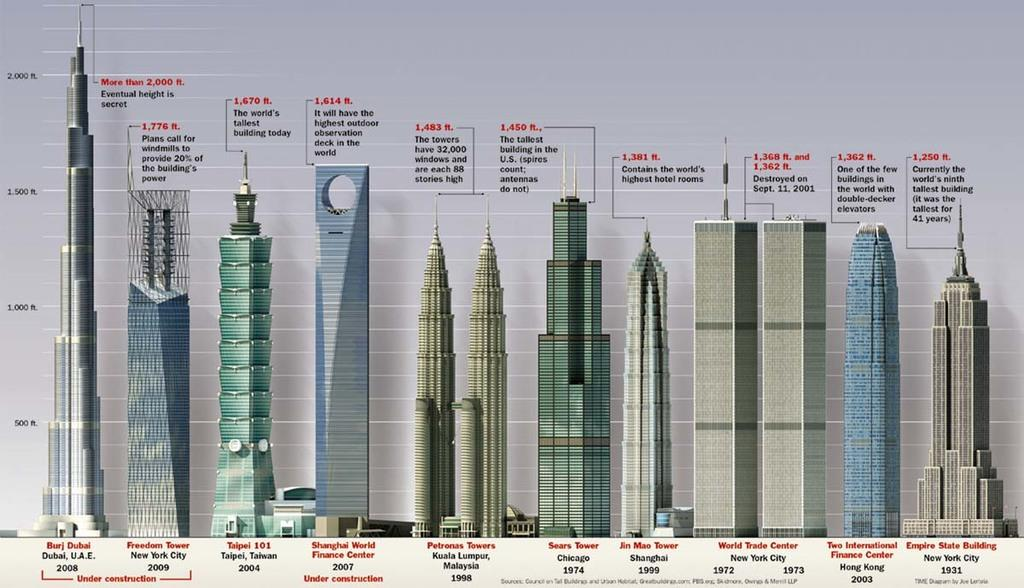What type of images are included in the picture? There are diagrams of buildings in the image. What additional information is provided on the diagrams? There is text present on the diagrams. Are there any numerical values included on the diagrams? Yes, there are numerical values on the diagrams. What type of mask is being worn by the building in the image? There is no mask present in the image, as it features diagrams of buildings. How does the behavior of the leaf affect the numerical values on the diagrams? There is no leaf present in the image, so its behavior cannot affect the numerical values on the diagrams. 